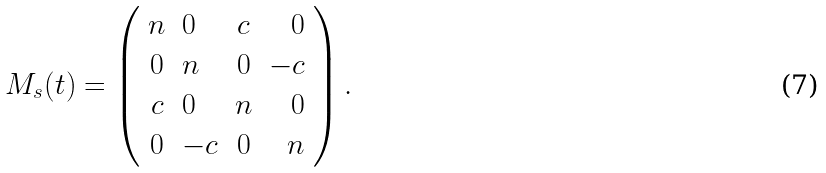Convert formula to latex. <formula><loc_0><loc_0><loc_500><loc_500>M _ { s } ( t ) = \left ( \begin{array} { c l c r } n & 0 & c & 0 \\ 0 & n & 0 & - c \\ c & 0 & n & 0 \\ 0 & - c & 0 & n \end{array} \right ) .</formula> 